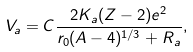<formula> <loc_0><loc_0><loc_500><loc_500>V _ { a } = C \frac { 2 K _ { a } ( Z - 2 ) e ^ { 2 } } { r _ { 0 } ( A - 4 ) ^ { 1 / 3 } + R _ { a } } ,</formula> 